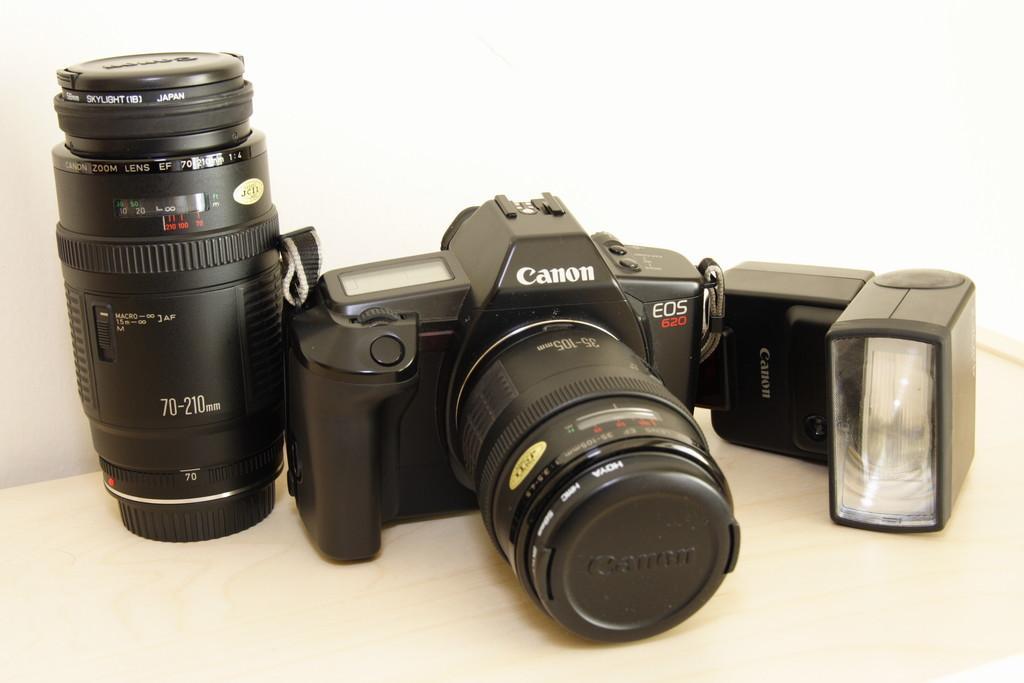Please provide a concise description of this image. In this picture we can see black canon camera in the middle. Beside there is a black lens and on the left side we can see the flash light. 